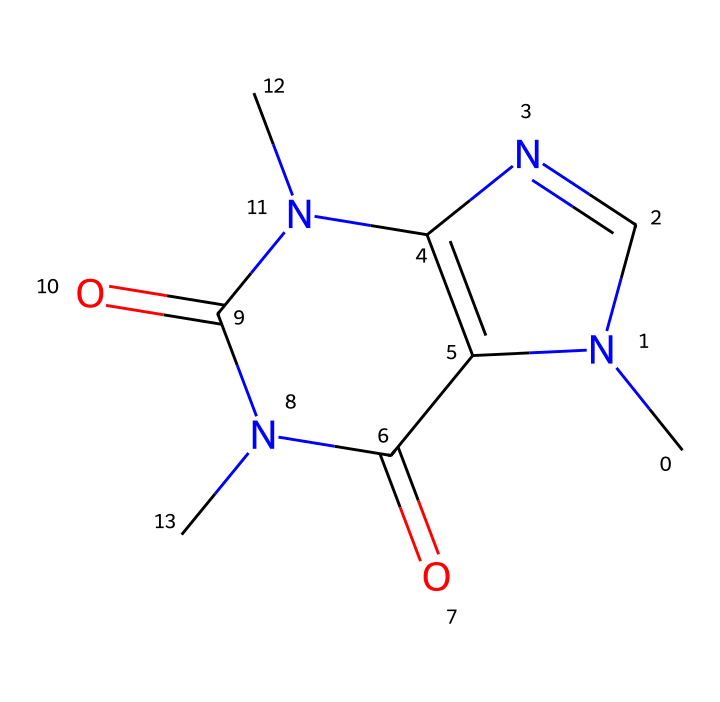What is the molecular formula of caffeine? To derive the molecular formula from the SMILES representation, we need to identify the types and numbers of atoms present. The structure can be analyzed and counted: there are 8 carbon (C) atoms, 10 hydrogen (H) atoms, 4 nitrogen (N) atoms, and 2 oxygen (O) atoms. Thus, the molecular formula can be formulated as C8H10N4O2.
Answer: C8H10N4O2 How many rings are present in the caffeine structure? Analyzing the structure, we can see that it consists of two connected ring systems, making up the bicyclic structure characteristic of caffeine.
Answer: 2 What type of bond is predominantly present in caffeine? By examining the structure, we notice a combination of single and double bonds, but the nitrogen atoms play a significant role here, as they are likely to participate in aromatic bonding and resonance, mainly indicating that the structure has many aromatic characteristics due to the nitrogen-cyclized rings.
Answer: aromatic Which element is not present in caffeine but is commonly found in phosphorus compounds? Caffeine's structure does not include phosphorus, which is a key element in various phosphorus compounds such as phosphates or phosphonates, commonly characterized by the presence of P in their structural formulas.
Answer: phosphorus How many nitrogen atoms are in caffeine? From counting the nitrogen symbols in the SMILES code, we find four nitrogen atoms present in the caffeine structure. Each nitrogen contributes to the structure's overall characteristics, including its solubility and biological activity.
Answer: 4 What functional group is present in caffeine? The structure displays a carbonyl group (C=O) within its arrangement, which is characteristic of amides due to the presence of nitrogen as well, leading to functional groups that affect its chemical behavior and properties.
Answer: carbonyl 